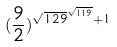Convert formula to latex. <formula><loc_0><loc_0><loc_500><loc_500>( \frac { 9 } { 2 } ) ^ { \sqrt { 1 2 9 } ^ { \sqrt { 1 1 9 } } + 1 }</formula> 